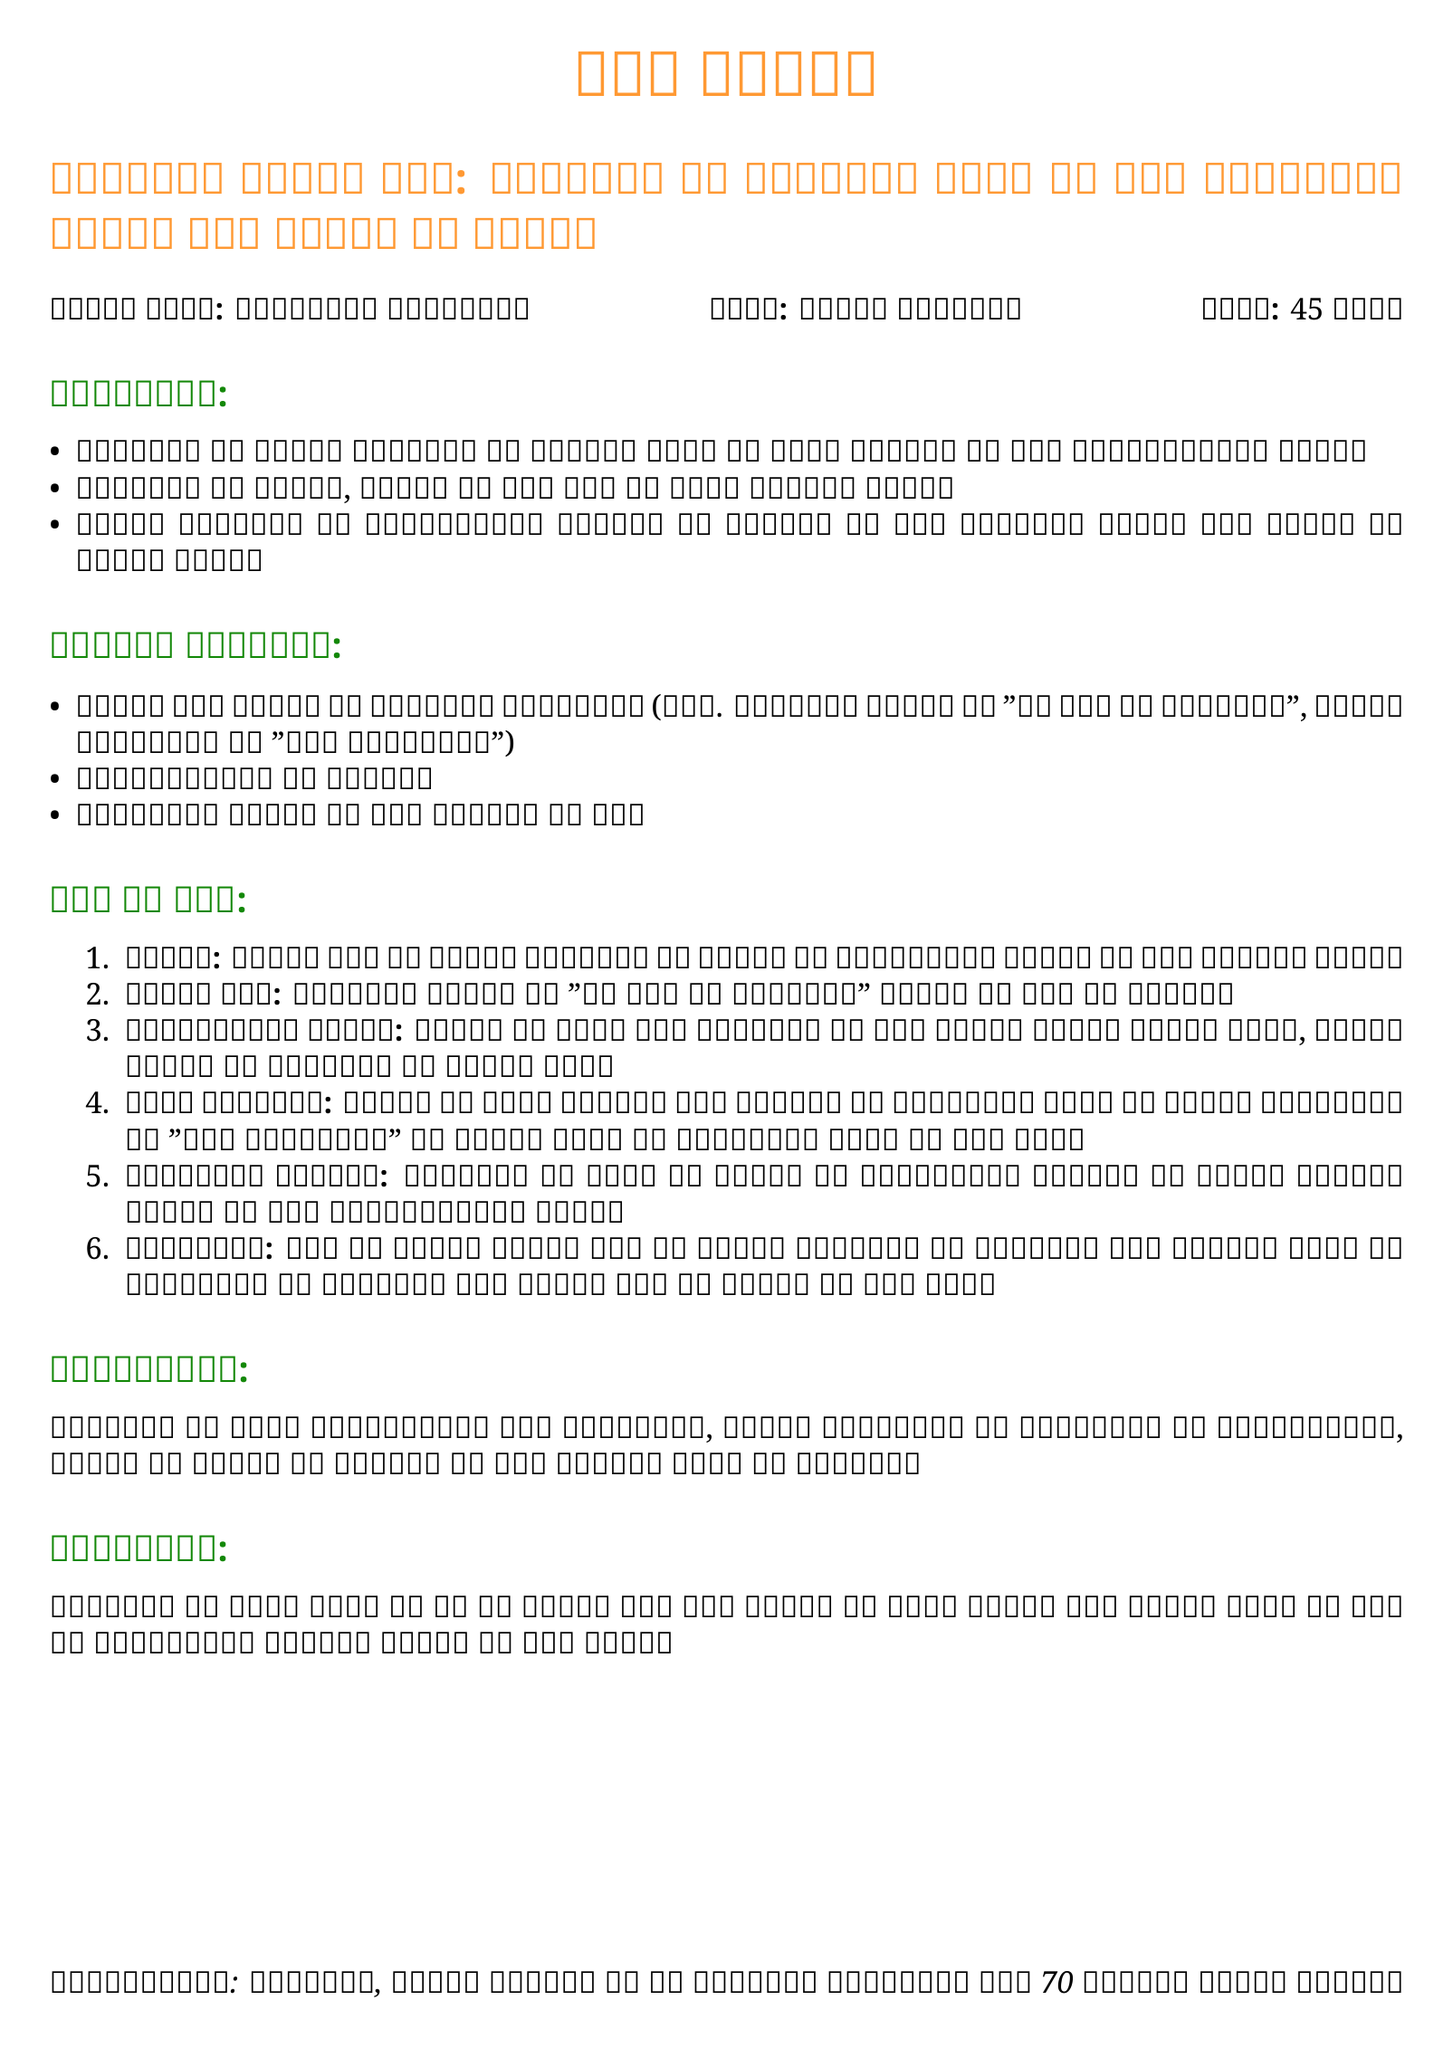what is the subject of the lesson plan? The subject of the lesson plan is stated as Hindi Literature.
Answer: Hindi Literature what is the duration of the lesson? The duration of the lesson is mentioned in the document as 45 minutes.
Answer: 45 minutes which stories are included in the materials required? The stories mentioned are "एक गधे की आत्मकथा" by हरिशंकर परसाई and "पंच परमेश्वर" by मुंशी प्रेमचंद.
Answer: "एक गधे की आत्मकथा", "पंच परमेश्वर" what is one of the objectives of the lesson? One of the objectives is to encourage students to appreciate and connect with Hindi literature.
Answer: appreciate and connect with Hindi literature how should students be assessed according to the lesson plan? Assessment is based on participation in discussions, quality of written summaries, and expression of understanding of themes.
Answer: participation, written summaries, understanding of themes what type of activities are included in the lesson plan? The activities include interactive discussions, group activities, and creative writing exercises.
Answer: discussions, group activities, writing exercises how are the students expected to engage with the stories? Students are expected to discuss the stories with their peers and write summaries or moral lessons about them.
Answer: discuss and write summaries or moral lessons what is the homework assigned to the students? The homework is to read another Hindi short story and write a brief summary for discussion in the next class.
Answer: read another story and write a brief summary 